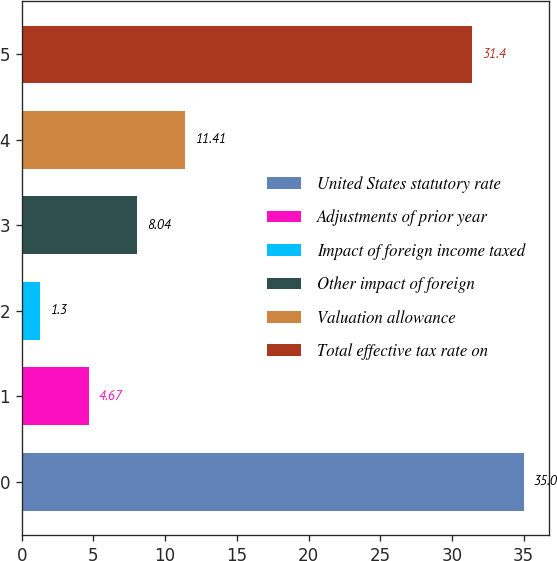<chart> <loc_0><loc_0><loc_500><loc_500><bar_chart><fcel>United States statutory rate<fcel>Adjustments of prior year<fcel>Impact of foreign income taxed<fcel>Other impact of foreign<fcel>Valuation allowance<fcel>Total effective tax rate on<nl><fcel>35<fcel>4.67<fcel>1.3<fcel>8.04<fcel>11.41<fcel>31.4<nl></chart> 